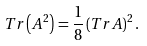<formula> <loc_0><loc_0><loc_500><loc_500>T r \left ( A ^ { 2 } \right ) = \frac { 1 } { 8 } \left ( T r A \right ) ^ { 2 } .</formula> 